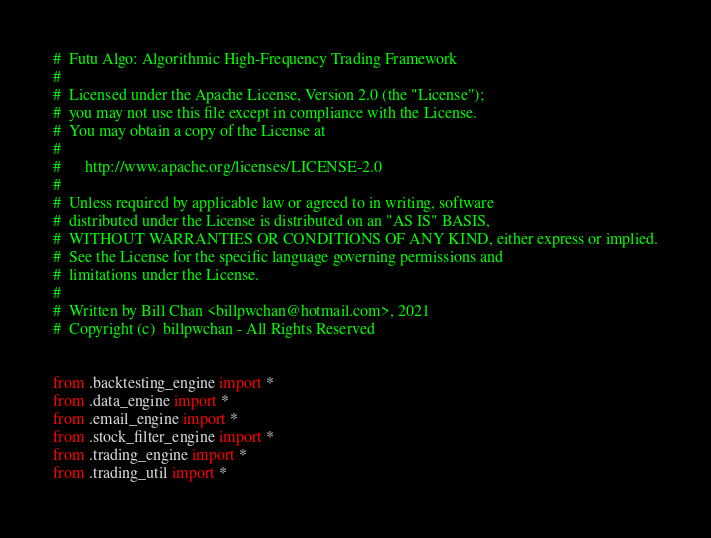<code> <loc_0><loc_0><loc_500><loc_500><_Python_>#  Futu Algo: Algorithmic High-Frequency Trading Framework
#
#  Licensed under the Apache License, Version 2.0 (the "License");
#  you may not use this file except in compliance with the License.
#  You may obtain a copy of the License at
#
#      http://www.apache.org/licenses/LICENSE-2.0
#
#  Unless required by applicable law or agreed to in writing, software
#  distributed under the License is distributed on an "AS IS" BASIS,
#  WITHOUT WARRANTIES OR CONDITIONS OF ANY KIND, either express or implied.
#  See the License for the specific language governing permissions and
#  limitations under the License.
#
#  Written by Bill Chan <billpwchan@hotmail.com>, 2021
#  Copyright (c)  billpwchan - All Rights Reserved


from .backtesting_engine import *
from .data_engine import *
from .email_engine import *
from .stock_filter_engine import *
from .trading_engine import *
from .trading_util import *
</code> 